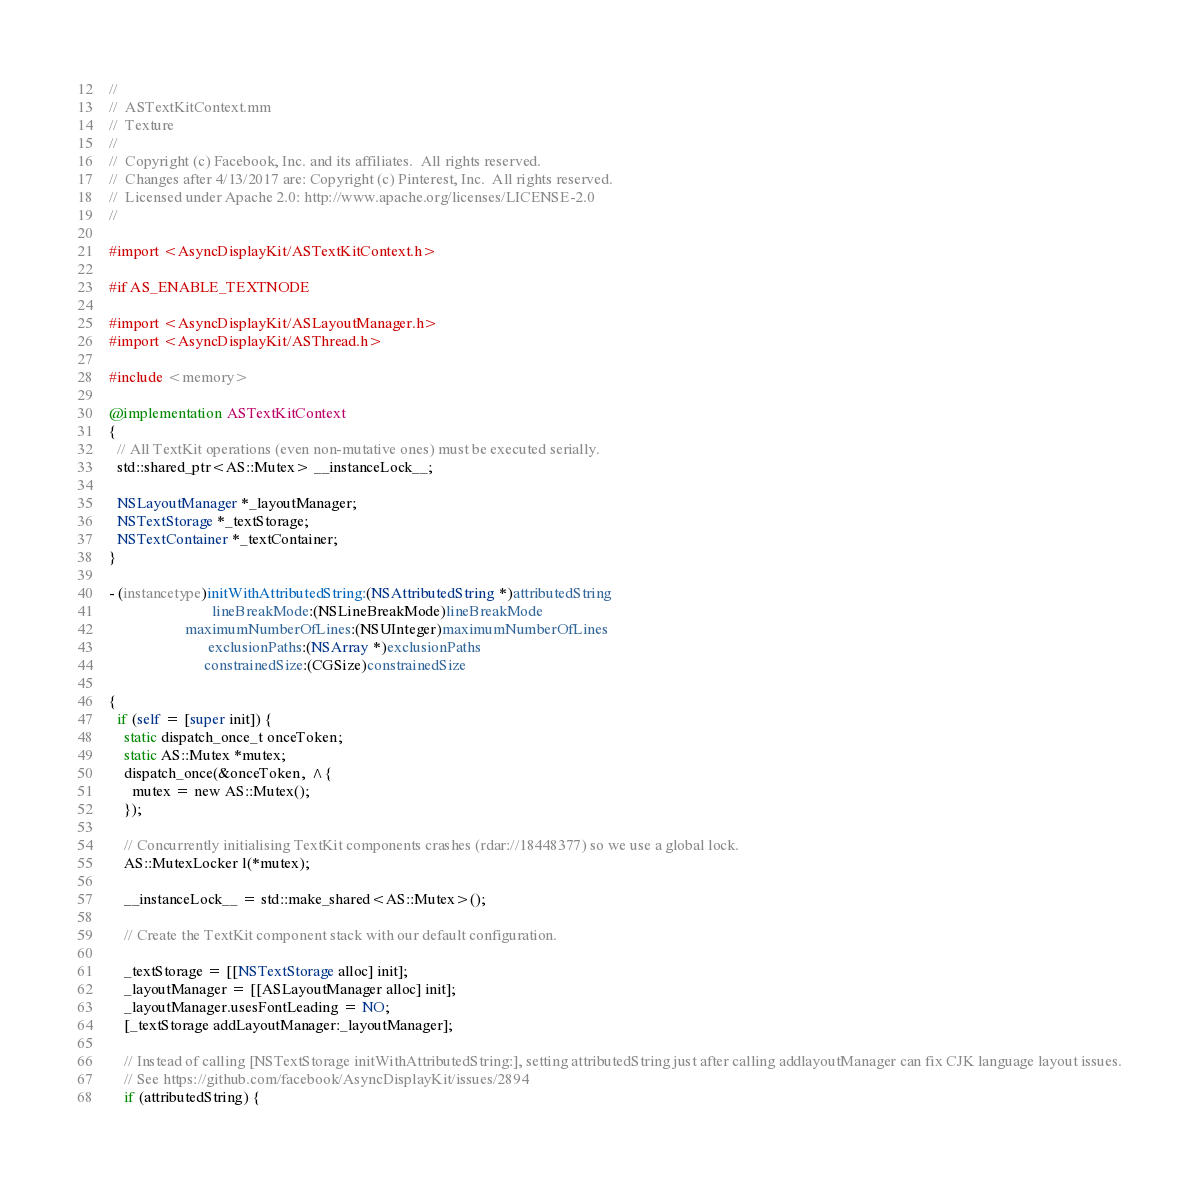<code> <loc_0><loc_0><loc_500><loc_500><_ObjectiveC_>//
//  ASTextKitContext.mm
//  Texture
//
//  Copyright (c) Facebook, Inc. and its affiliates.  All rights reserved.
//  Changes after 4/13/2017 are: Copyright (c) Pinterest, Inc.  All rights reserved.
//  Licensed under Apache 2.0: http://www.apache.org/licenses/LICENSE-2.0
//

#import <AsyncDisplayKit/ASTextKitContext.h>

#if AS_ENABLE_TEXTNODE

#import <AsyncDisplayKit/ASLayoutManager.h>
#import <AsyncDisplayKit/ASThread.h>

#include <memory>

@implementation ASTextKitContext
{
  // All TextKit operations (even non-mutative ones) must be executed serially.
  std::shared_ptr<AS::Mutex> __instanceLock__;

  NSLayoutManager *_layoutManager;
  NSTextStorage *_textStorage;
  NSTextContainer *_textContainer;
}

- (instancetype)initWithAttributedString:(NSAttributedString *)attributedString
                           lineBreakMode:(NSLineBreakMode)lineBreakMode
                    maximumNumberOfLines:(NSUInteger)maximumNumberOfLines
                          exclusionPaths:(NSArray *)exclusionPaths
                         constrainedSize:(CGSize)constrainedSize

{
  if (self = [super init]) {
    static dispatch_once_t onceToken;
    static AS::Mutex *mutex;
    dispatch_once(&onceToken, ^{
      mutex = new AS::Mutex();
    });
    
    // Concurrently initialising TextKit components crashes (rdar://18448377) so we use a global lock.
    AS::MutexLocker l(*mutex);
    
    __instanceLock__ = std::make_shared<AS::Mutex>();
    
    // Create the TextKit component stack with our default configuration.
    
    _textStorage = [[NSTextStorage alloc] init];
    _layoutManager = [[ASLayoutManager alloc] init];
    _layoutManager.usesFontLeading = NO;
    [_textStorage addLayoutManager:_layoutManager];
    
    // Instead of calling [NSTextStorage initWithAttributedString:], setting attributedString just after calling addlayoutManager can fix CJK language layout issues.
    // See https://github.com/facebook/AsyncDisplayKit/issues/2894
    if (attributedString) {</code> 